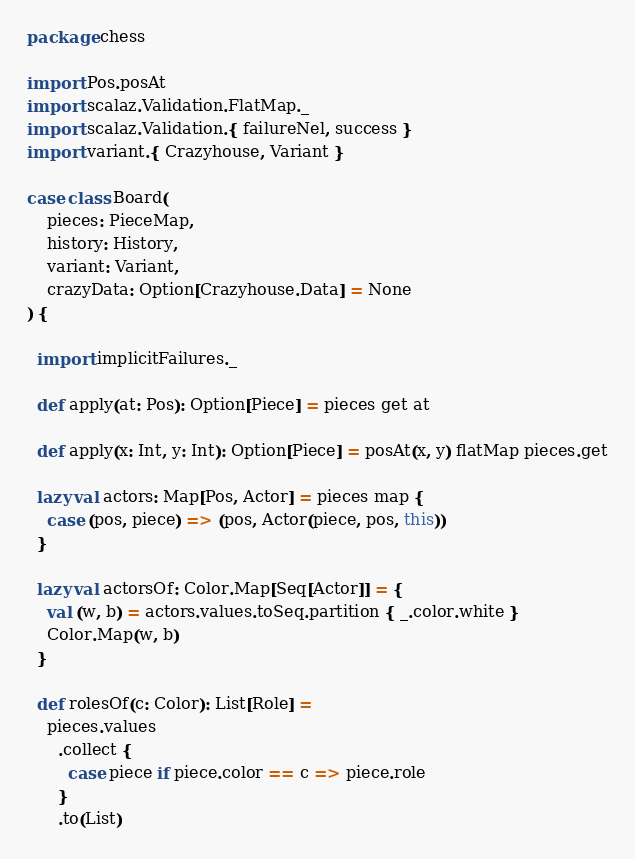<code> <loc_0><loc_0><loc_500><loc_500><_Scala_>package chess

import Pos.posAt
import scalaz.Validation.FlatMap._
import scalaz.Validation.{ failureNel, success }
import variant.{ Crazyhouse, Variant }

case class Board(
    pieces: PieceMap,
    history: History,
    variant: Variant,
    crazyData: Option[Crazyhouse.Data] = None
) {

  import implicitFailures._

  def apply(at: Pos): Option[Piece] = pieces get at

  def apply(x: Int, y: Int): Option[Piece] = posAt(x, y) flatMap pieces.get

  lazy val actors: Map[Pos, Actor] = pieces map {
    case (pos, piece) => (pos, Actor(piece, pos, this))
  }

  lazy val actorsOf: Color.Map[Seq[Actor]] = {
    val (w, b) = actors.values.toSeq.partition { _.color.white }
    Color.Map(w, b)
  }

  def rolesOf(c: Color): List[Role] =
    pieces.values
      .collect {
        case piece if piece.color == c => piece.role
      }
      .to(List)
</code> 